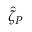<formula> <loc_0><loc_0><loc_500><loc_500>\hat { \zeta } _ { P }</formula> 